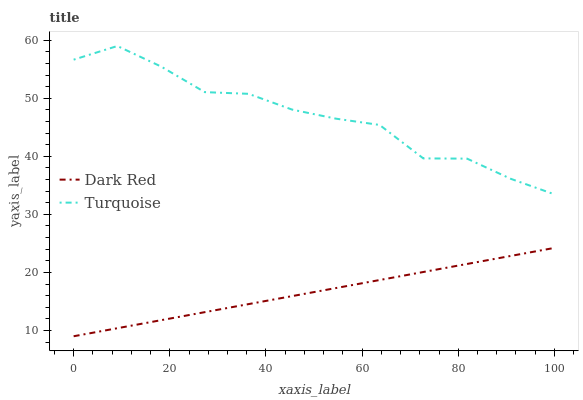Does Dark Red have the minimum area under the curve?
Answer yes or no. Yes. Does Turquoise have the maximum area under the curve?
Answer yes or no. Yes. Does Turquoise have the minimum area under the curve?
Answer yes or no. No. Is Dark Red the smoothest?
Answer yes or no. Yes. Is Turquoise the roughest?
Answer yes or no. Yes. Is Turquoise the smoothest?
Answer yes or no. No. Does Turquoise have the lowest value?
Answer yes or no. No. Is Dark Red less than Turquoise?
Answer yes or no. Yes. Is Turquoise greater than Dark Red?
Answer yes or no. Yes. Does Dark Red intersect Turquoise?
Answer yes or no. No. 